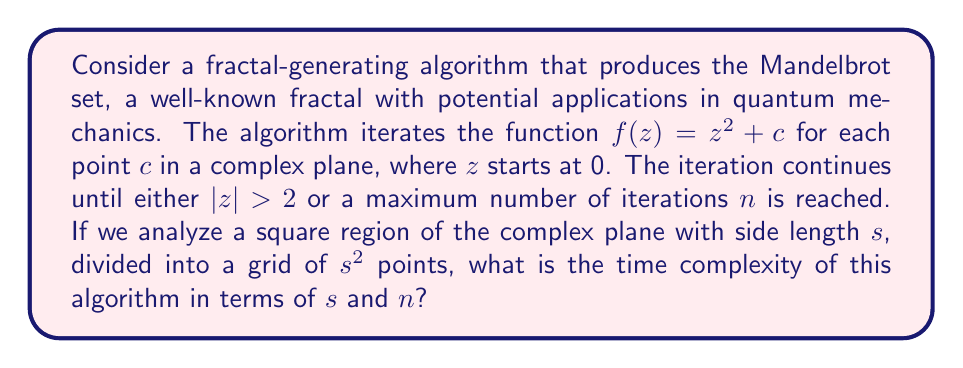Give your solution to this math problem. To analyze the time complexity of this fractal-generating algorithm, we need to consider the following steps:

1. The algorithm processes a square region of side length $s$, which contains $s^2$ points.

2. For each point, we perform up to $n$ iterations of the function $f(z) = z^2 + c$.

3. Each iteration involves:
   a. Complex number multiplication: $O(1)$
   b. Complex number addition: $O(1)$
   c. Magnitude calculation and comparison: $O(1)$

4. The total number of operations for each point is therefore $O(n)$.

5. Since we perform these operations for all $s^2$ points, the total number of operations is:

   $$O(s^2 \cdot n)$$

This analysis assumes that the precision of the calculations remains constant. In practice, the precision required might increase with $n$, which could add a logarithmic factor. However, for standard implementations, this factor is usually negligible.

From a quantum mechanics perspective, this time complexity is particularly relevant when considering the computational resources required to generate high-resolution fractal images that might serve as models for quantum phenomena. The quadratic dependence on $s$ indicates that doubling the resolution increases the computation time by a factor of 4, which could be significant when exploring fine-grained quantum structures.
Answer: The time complexity of the Mandelbrot set generating algorithm for a square region of side length $s$ with a maximum of $n$ iterations is $O(s^2n)$. 